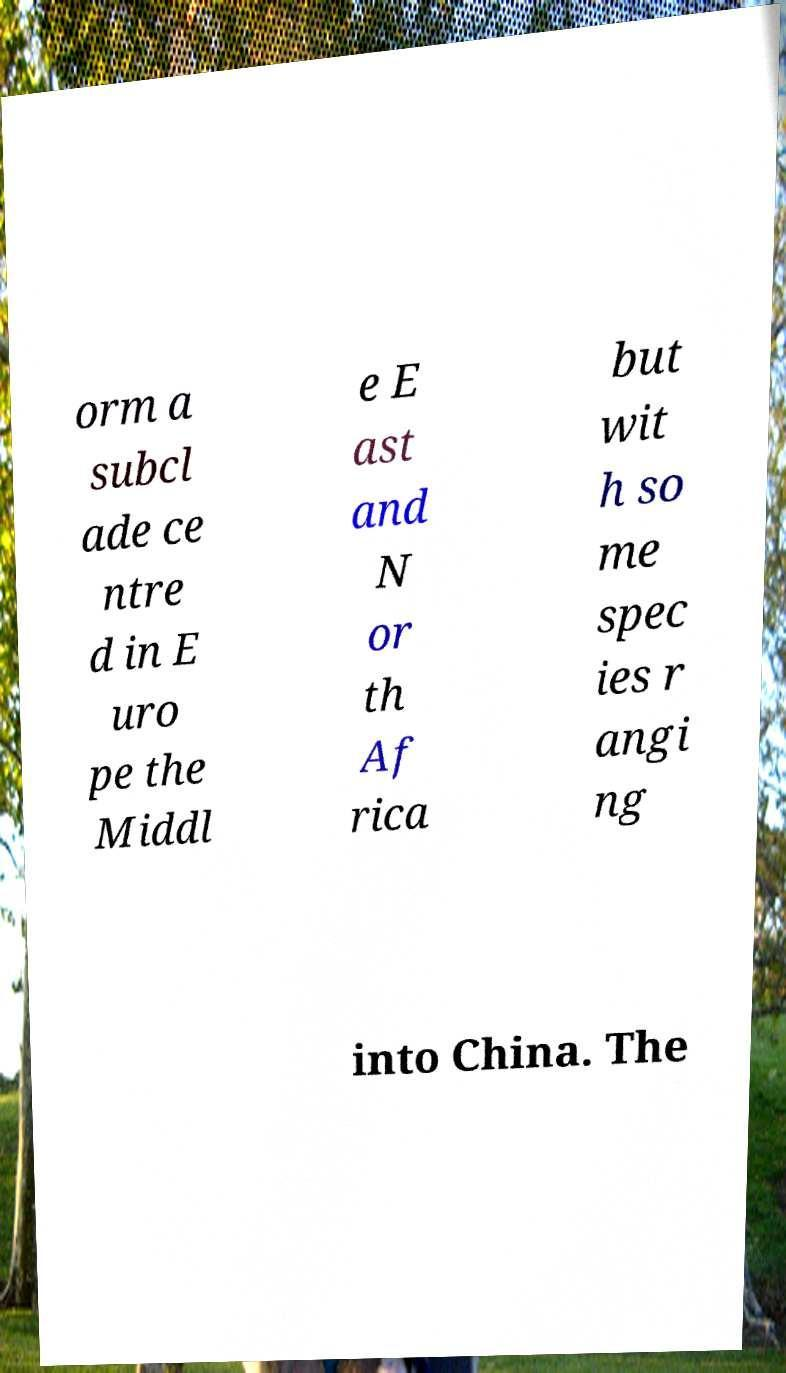What messages or text are displayed in this image? I need them in a readable, typed format. orm a subcl ade ce ntre d in E uro pe the Middl e E ast and N or th Af rica but wit h so me spec ies r angi ng into China. The 